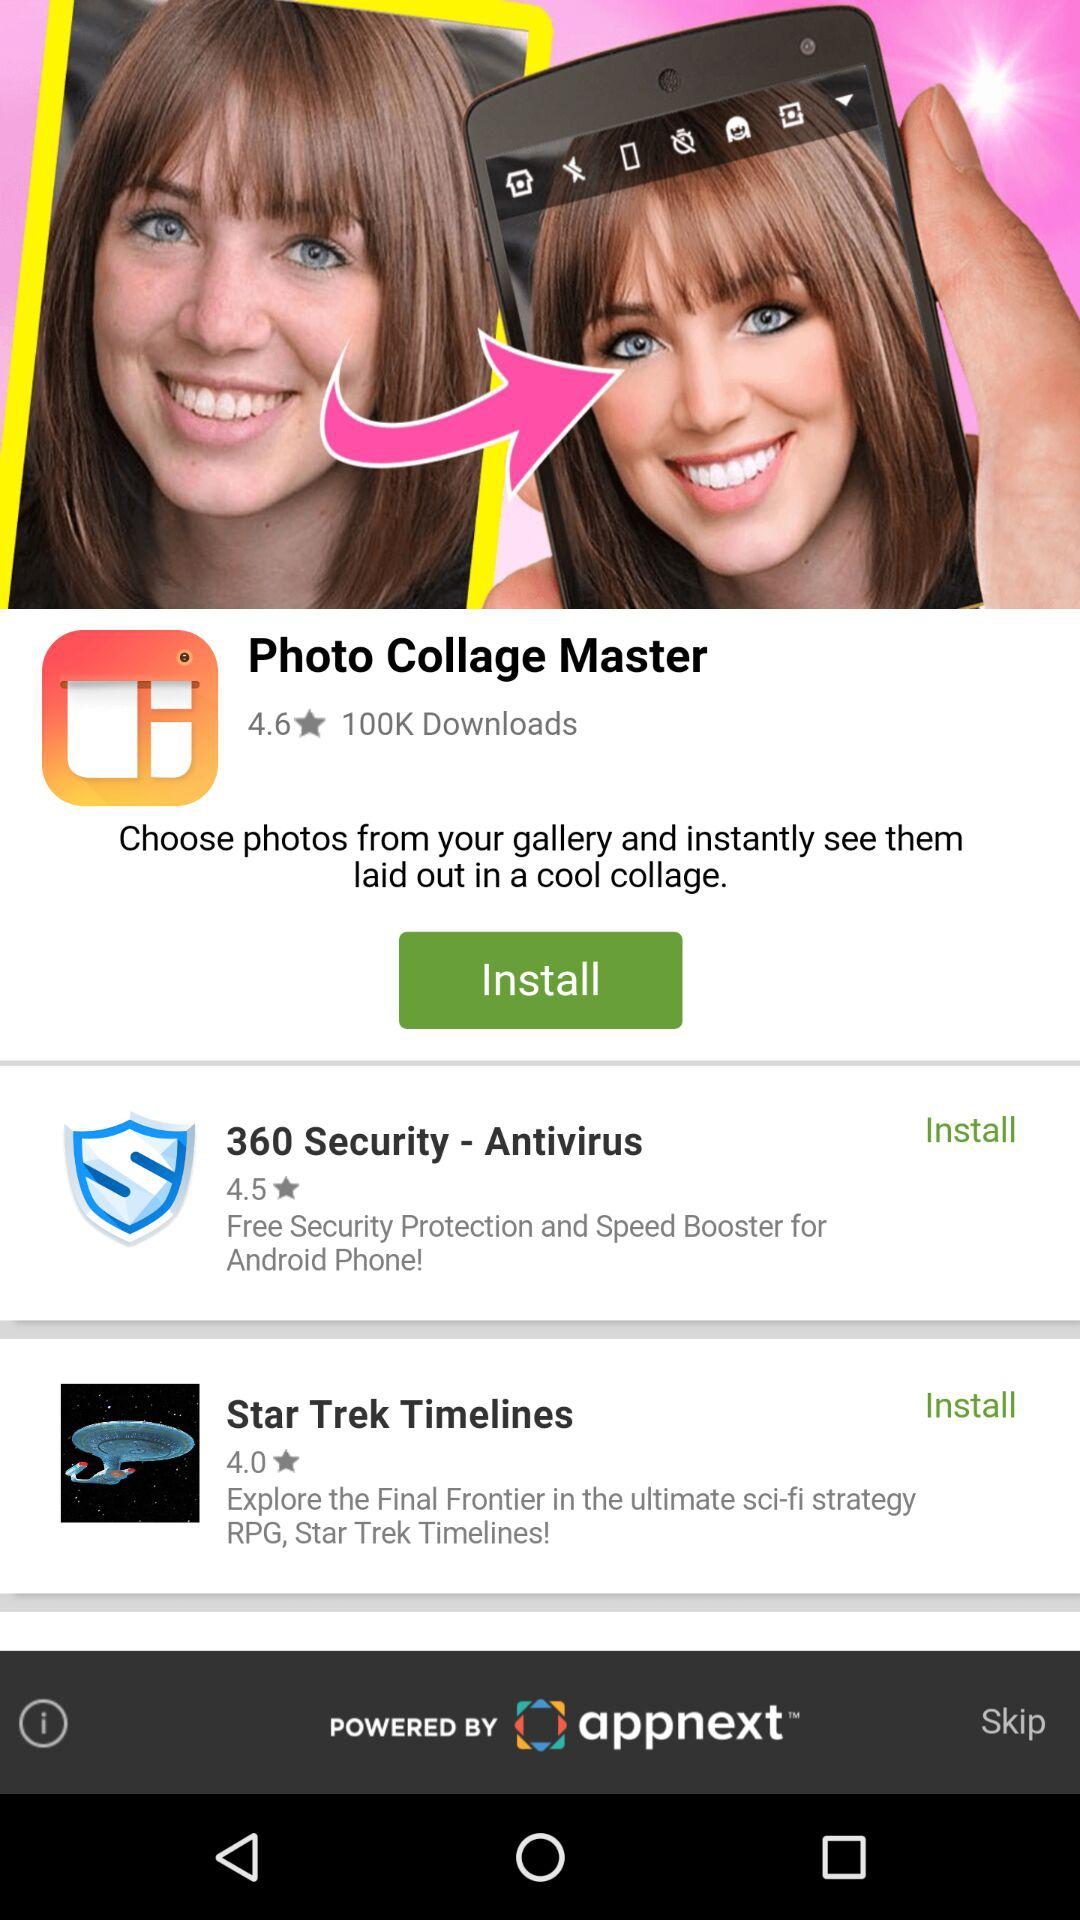Which application has the lowest rating?
When the provided information is insufficient, respond with <no answer>. <no answer> 